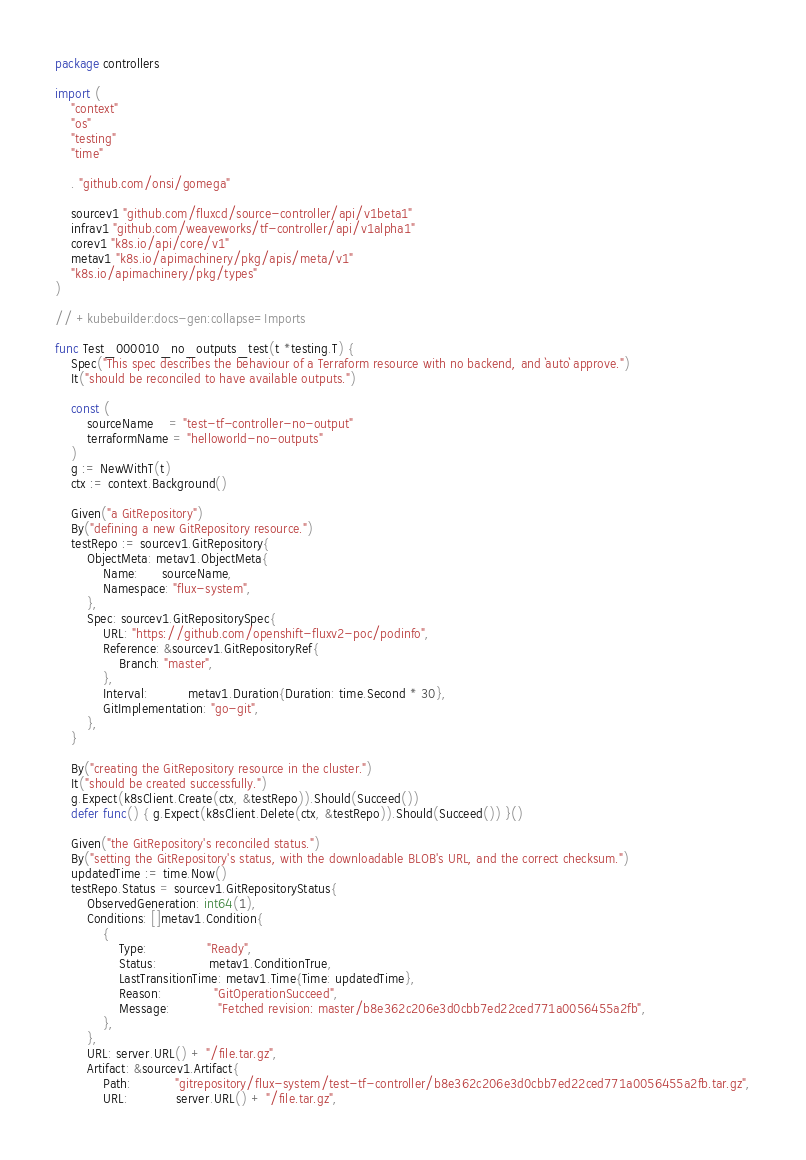<code> <loc_0><loc_0><loc_500><loc_500><_Go_>package controllers

import (
	"context"
	"os"
	"testing"
	"time"

	. "github.com/onsi/gomega"

	sourcev1 "github.com/fluxcd/source-controller/api/v1beta1"
	infrav1 "github.com/weaveworks/tf-controller/api/v1alpha1"
	corev1 "k8s.io/api/core/v1"
	metav1 "k8s.io/apimachinery/pkg/apis/meta/v1"
	"k8s.io/apimachinery/pkg/types"
)

// +kubebuilder:docs-gen:collapse=Imports

func Test_000010_no_outputs_test(t *testing.T) {
	Spec("This spec describes the behaviour of a Terraform resource with no backend, and `auto` approve.")
	It("should be reconciled to have available outputs.")

	const (
		sourceName    = "test-tf-controller-no-output"
		terraformName = "helloworld-no-outputs"
	)
	g := NewWithT(t)
	ctx := context.Background()

	Given("a GitRepository")
	By("defining a new GitRepository resource.")
	testRepo := sourcev1.GitRepository{
		ObjectMeta: metav1.ObjectMeta{
			Name:      sourceName,
			Namespace: "flux-system",
		},
		Spec: sourcev1.GitRepositorySpec{
			URL: "https://github.com/openshift-fluxv2-poc/podinfo",
			Reference: &sourcev1.GitRepositoryRef{
				Branch: "master",
			},
			Interval:          metav1.Duration{Duration: time.Second * 30},
			GitImplementation: "go-git",
		},
	}

	By("creating the GitRepository resource in the cluster.")
	It("should be created successfully.")
	g.Expect(k8sClient.Create(ctx, &testRepo)).Should(Succeed())
	defer func() { g.Expect(k8sClient.Delete(ctx, &testRepo)).Should(Succeed()) }()

	Given("the GitRepository's reconciled status.")
	By("setting the GitRepository's status, with the downloadable BLOB's URL, and the correct checksum.")
	updatedTime := time.Now()
	testRepo.Status = sourcev1.GitRepositoryStatus{
		ObservedGeneration: int64(1),
		Conditions: []metav1.Condition{
			{
				Type:               "Ready",
				Status:             metav1.ConditionTrue,
				LastTransitionTime: metav1.Time{Time: updatedTime},
				Reason:             "GitOperationSucceed",
				Message:            "Fetched revision: master/b8e362c206e3d0cbb7ed22ced771a0056455a2fb",
			},
		},
		URL: server.URL() + "/file.tar.gz",
		Artifact: &sourcev1.Artifact{
			Path:           "gitrepository/flux-system/test-tf-controller/b8e362c206e3d0cbb7ed22ced771a0056455a2fb.tar.gz",
			URL:            server.URL() + "/file.tar.gz",</code> 